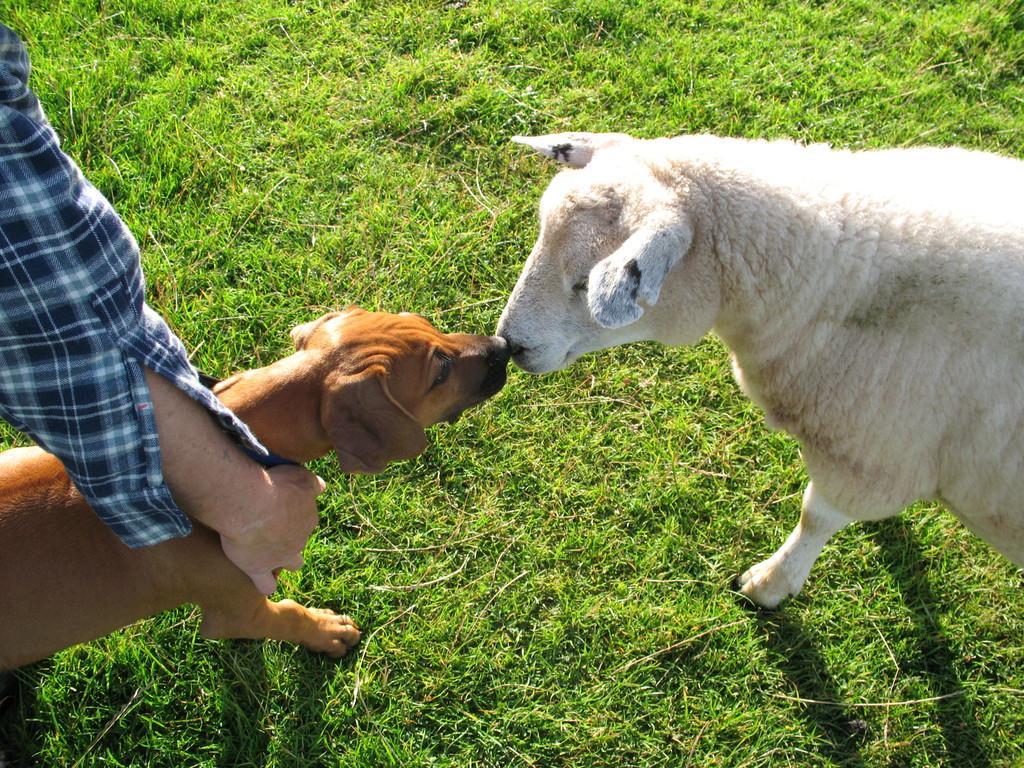How would you summarize this image in a sentence or two? In this image we can see a dog and the sheep on the grass. Here we can see a person's hand, wearing checked shirt. 